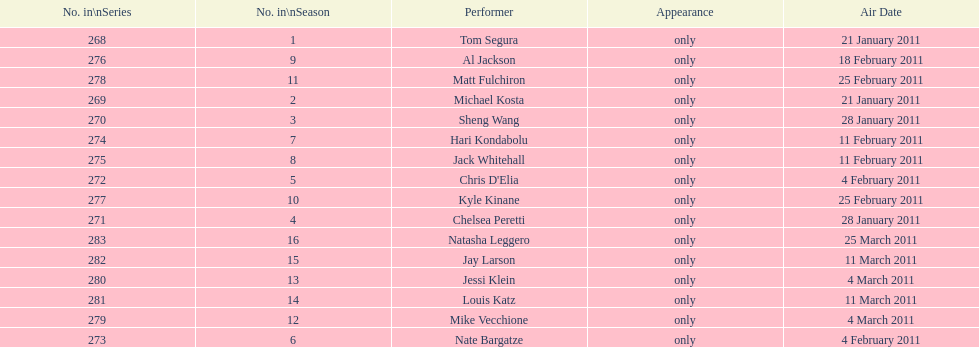Who appeared first tom segura or jay larson? Tom Segura. 